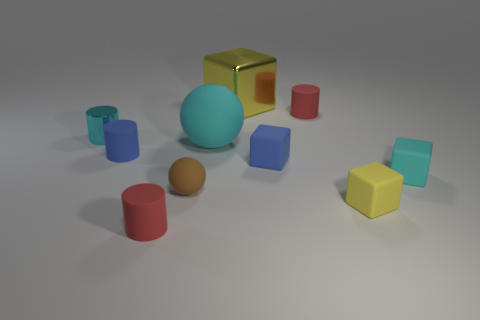What is the material of the other block that is the same color as the large metal cube?
Offer a very short reply. Rubber. What number of other things are there of the same color as the big shiny object?
Ensure brevity in your answer.  1. Is the size of the cyan block the same as the blue thing that is to the right of the yellow metal thing?
Provide a short and direct response. Yes. How many other objects are there of the same material as the large cyan thing?
Your response must be concise. 7. How many objects are red objects to the right of the brown matte object or tiny red rubber cylinders behind the brown rubber ball?
Give a very brief answer. 1. There is another large yellow thing that is the same shape as the yellow matte object; what is it made of?
Your answer should be compact. Metal. Are there any blue metal things?
Your answer should be compact. No. There is a cyan object that is on the left side of the large yellow block and in front of the cyan shiny cylinder; what size is it?
Offer a very short reply. Large. There is a small cyan shiny thing; what shape is it?
Keep it short and to the point. Cylinder. There is a tiny blue object right of the big yellow cube; is there a red cylinder right of it?
Give a very brief answer. Yes. 